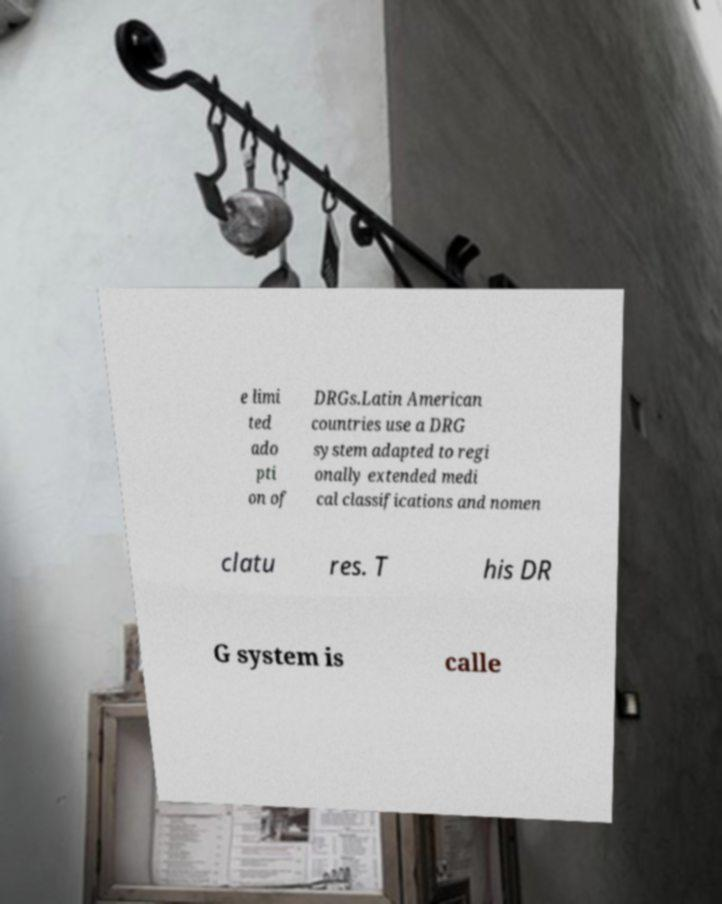Can you accurately transcribe the text from the provided image for me? e limi ted ado pti on of DRGs.Latin American countries use a DRG system adapted to regi onally extended medi cal classifications and nomen clatu res. T his DR G system is calle 